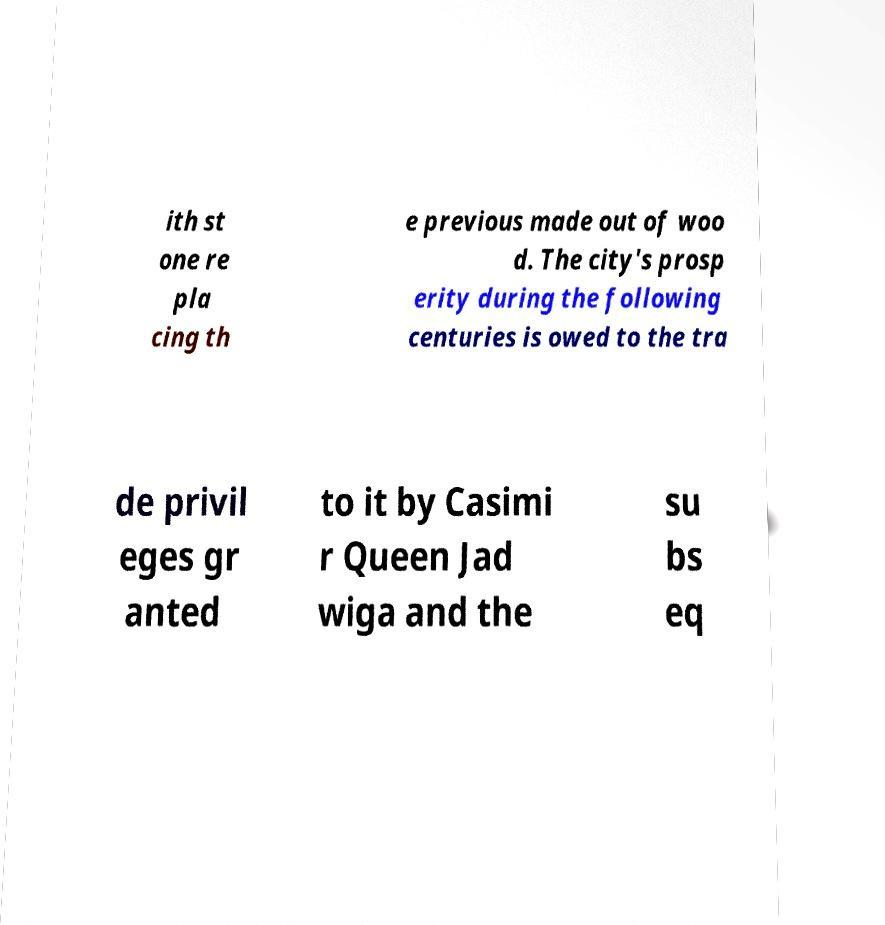Could you assist in decoding the text presented in this image and type it out clearly? ith st one re pla cing th e previous made out of woo d. The city's prosp erity during the following centuries is owed to the tra de privil eges gr anted to it by Casimi r Queen Jad wiga and the su bs eq 